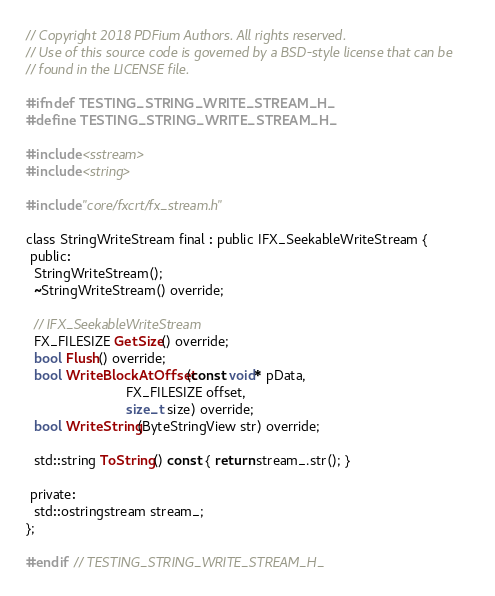<code> <loc_0><loc_0><loc_500><loc_500><_C_>// Copyright 2018 PDFium Authors. All rights reserved.
// Use of this source code is governed by a BSD-style license that can be
// found in the LICENSE file.

#ifndef TESTING_STRING_WRITE_STREAM_H_
#define TESTING_STRING_WRITE_STREAM_H_

#include <sstream>
#include <string>

#include "core/fxcrt/fx_stream.h"

class StringWriteStream final : public IFX_SeekableWriteStream {
 public:
  StringWriteStream();
  ~StringWriteStream() override;

  // IFX_SeekableWriteStream
  FX_FILESIZE GetSize() override;
  bool Flush() override;
  bool WriteBlockAtOffset(const void* pData,
                          FX_FILESIZE offset,
                          size_t size) override;
  bool WriteString(ByteStringView str) override;

  std::string ToString() const { return stream_.str(); }

 private:
  std::ostringstream stream_;
};

#endif  // TESTING_STRING_WRITE_STREAM_H_
</code> 